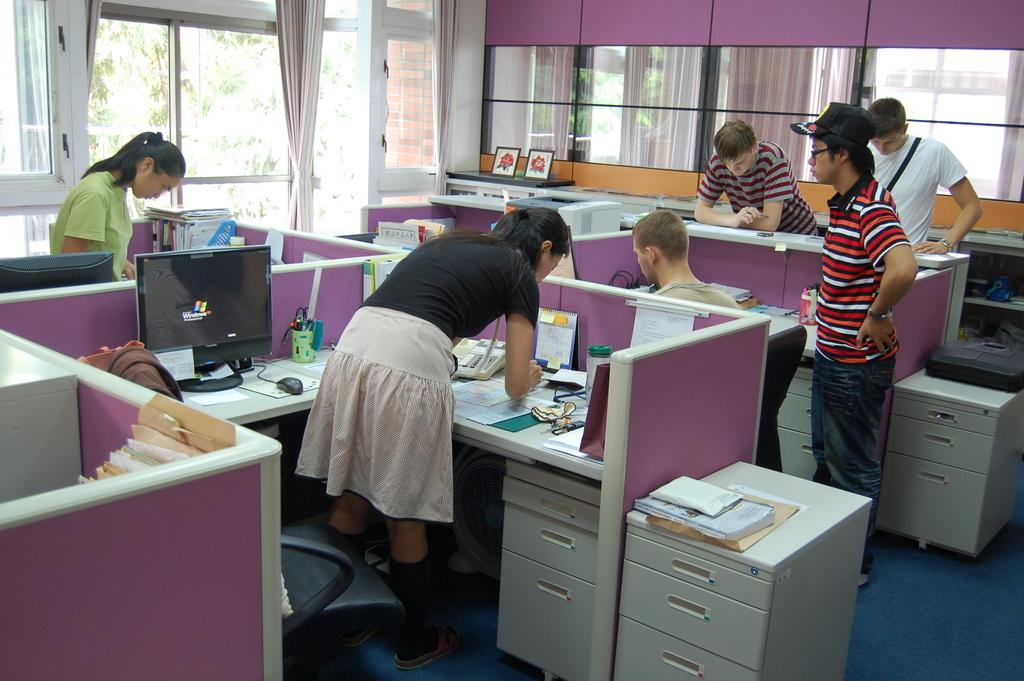What are the people in the image doing? There are three people working in the image. Can you describe the position of the other three people in the image? There are three people standing on the right side in the image. What type of nail is being used by the people in the image? There is no nail visible in the image, and it is not mentioned that the people are using a nail for their work. 